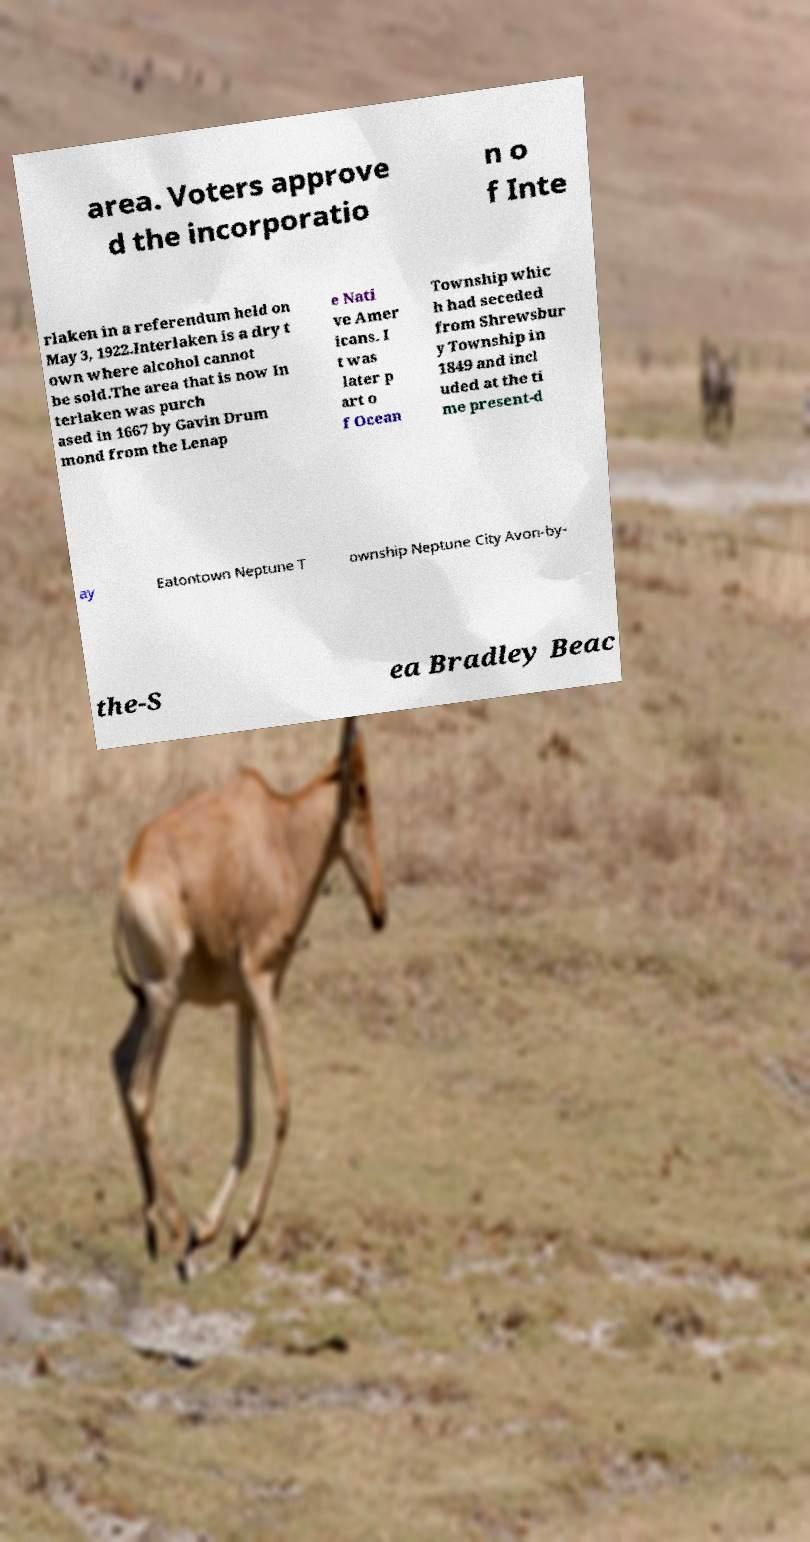For documentation purposes, I need the text within this image transcribed. Could you provide that? area. Voters approve d the incorporatio n o f Inte rlaken in a referendum held on May 3, 1922.Interlaken is a dry t own where alcohol cannot be sold.The area that is now In terlaken was purch ased in 1667 by Gavin Drum mond from the Lenap e Nati ve Amer icans. I t was later p art o f Ocean Township whic h had seceded from Shrewsbur y Township in 1849 and incl uded at the ti me present-d ay Eatontown Neptune T ownship Neptune City Avon-by- the-S ea Bradley Beac 